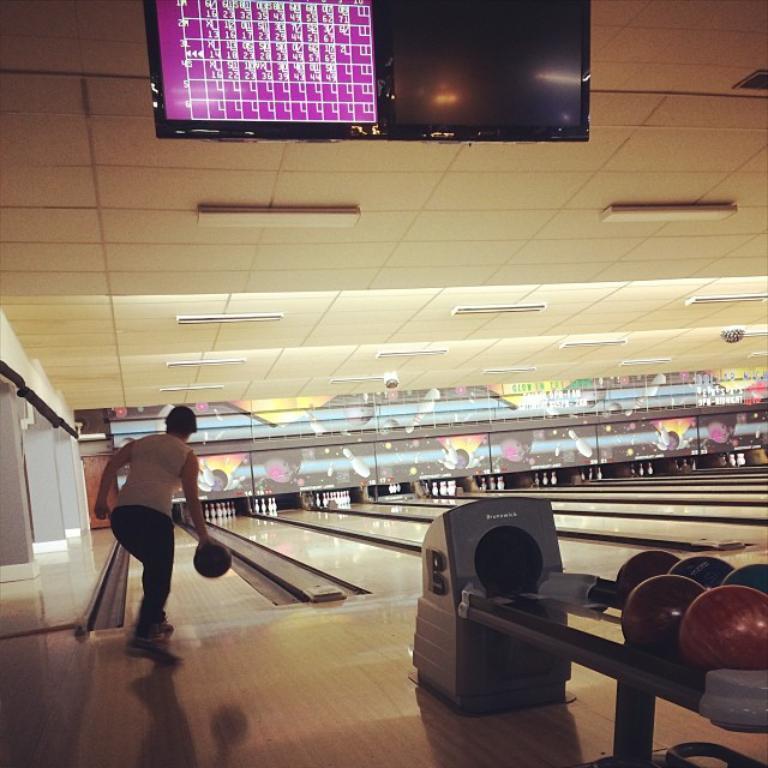Could you give a brief overview of what you see in this image? In this picture I can observe a woman standing on the left side. She is playing bowling. On the right side I can observe bowling balls. In the background there are bowling pins which are in white color. On the top of the picture I can observe a screen. 